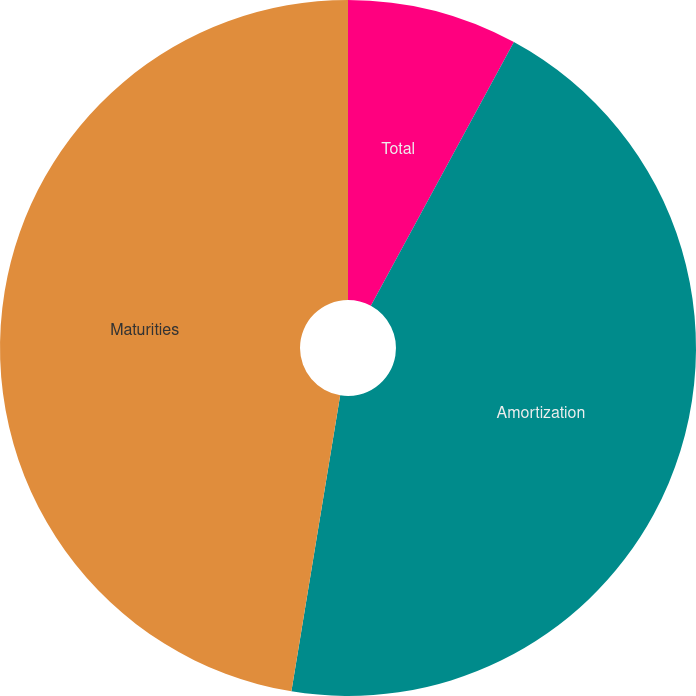Convert chart. <chart><loc_0><loc_0><loc_500><loc_500><pie_chart><fcel>Total<fcel>Amortization<fcel>Maturities<nl><fcel>7.91%<fcel>44.69%<fcel>47.4%<nl></chart> 